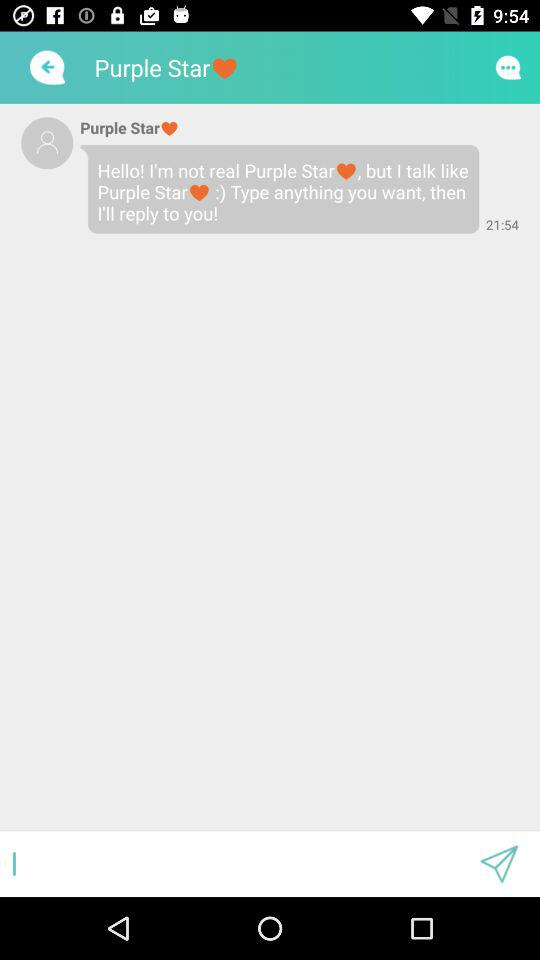What is the time of the message? The time of the message is 21:54. 